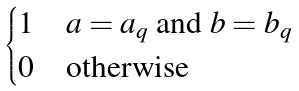<formula> <loc_0><loc_0><loc_500><loc_500>\begin{cases} 1 & a = a _ { q } \text { and } b = b _ { q } \\ 0 & \text {otherwise} \end{cases}</formula> 